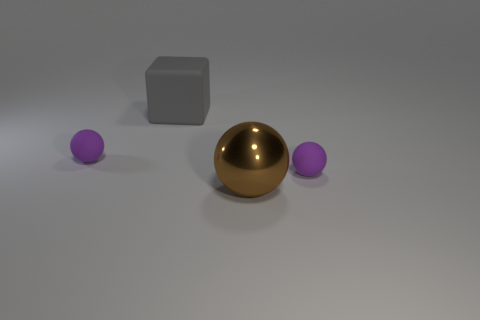Is there any other thing that is made of the same material as the large brown sphere?
Provide a short and direct response. No. Is the large shiny thing the same color as the block?
Offer a terse response. No. Is the number of yellow matte spheres less than the number of purple things?
Your answer should be very brief. Yes. How many cyan metal cubes are there?
Provide a short and direct response. 0. Is the number of metal objects to the left of the large gray rubber block less than the number of tiny objects?
Give a very brief answer. Yes. Do the tiny purple ball that is to the right of the brown sphere and the gray object have the same material?
Offer a terse response. Yes. What shape is the purple rubber object that is on the right side of the big gray object that is behind the purple thing that is to the right of the brown ball?
Ensure brevity in your answer.  Sphere. Are there any brown balls that have the same size as the gray block?
Make the answer very short. Yes. What is the size of the block?
Offer a very short reply. Large. How many purple spheres are the same size as the brown thing?
Your answer should be very brief. 0. 